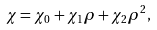<formula> <loc_0><loc_0><loc_500><loc_500>\chi = \chi _ { 0 } + \chi _ { 1 } \rho + \chi _ { 2 } \rho ^ { 2 } ,</formula> 